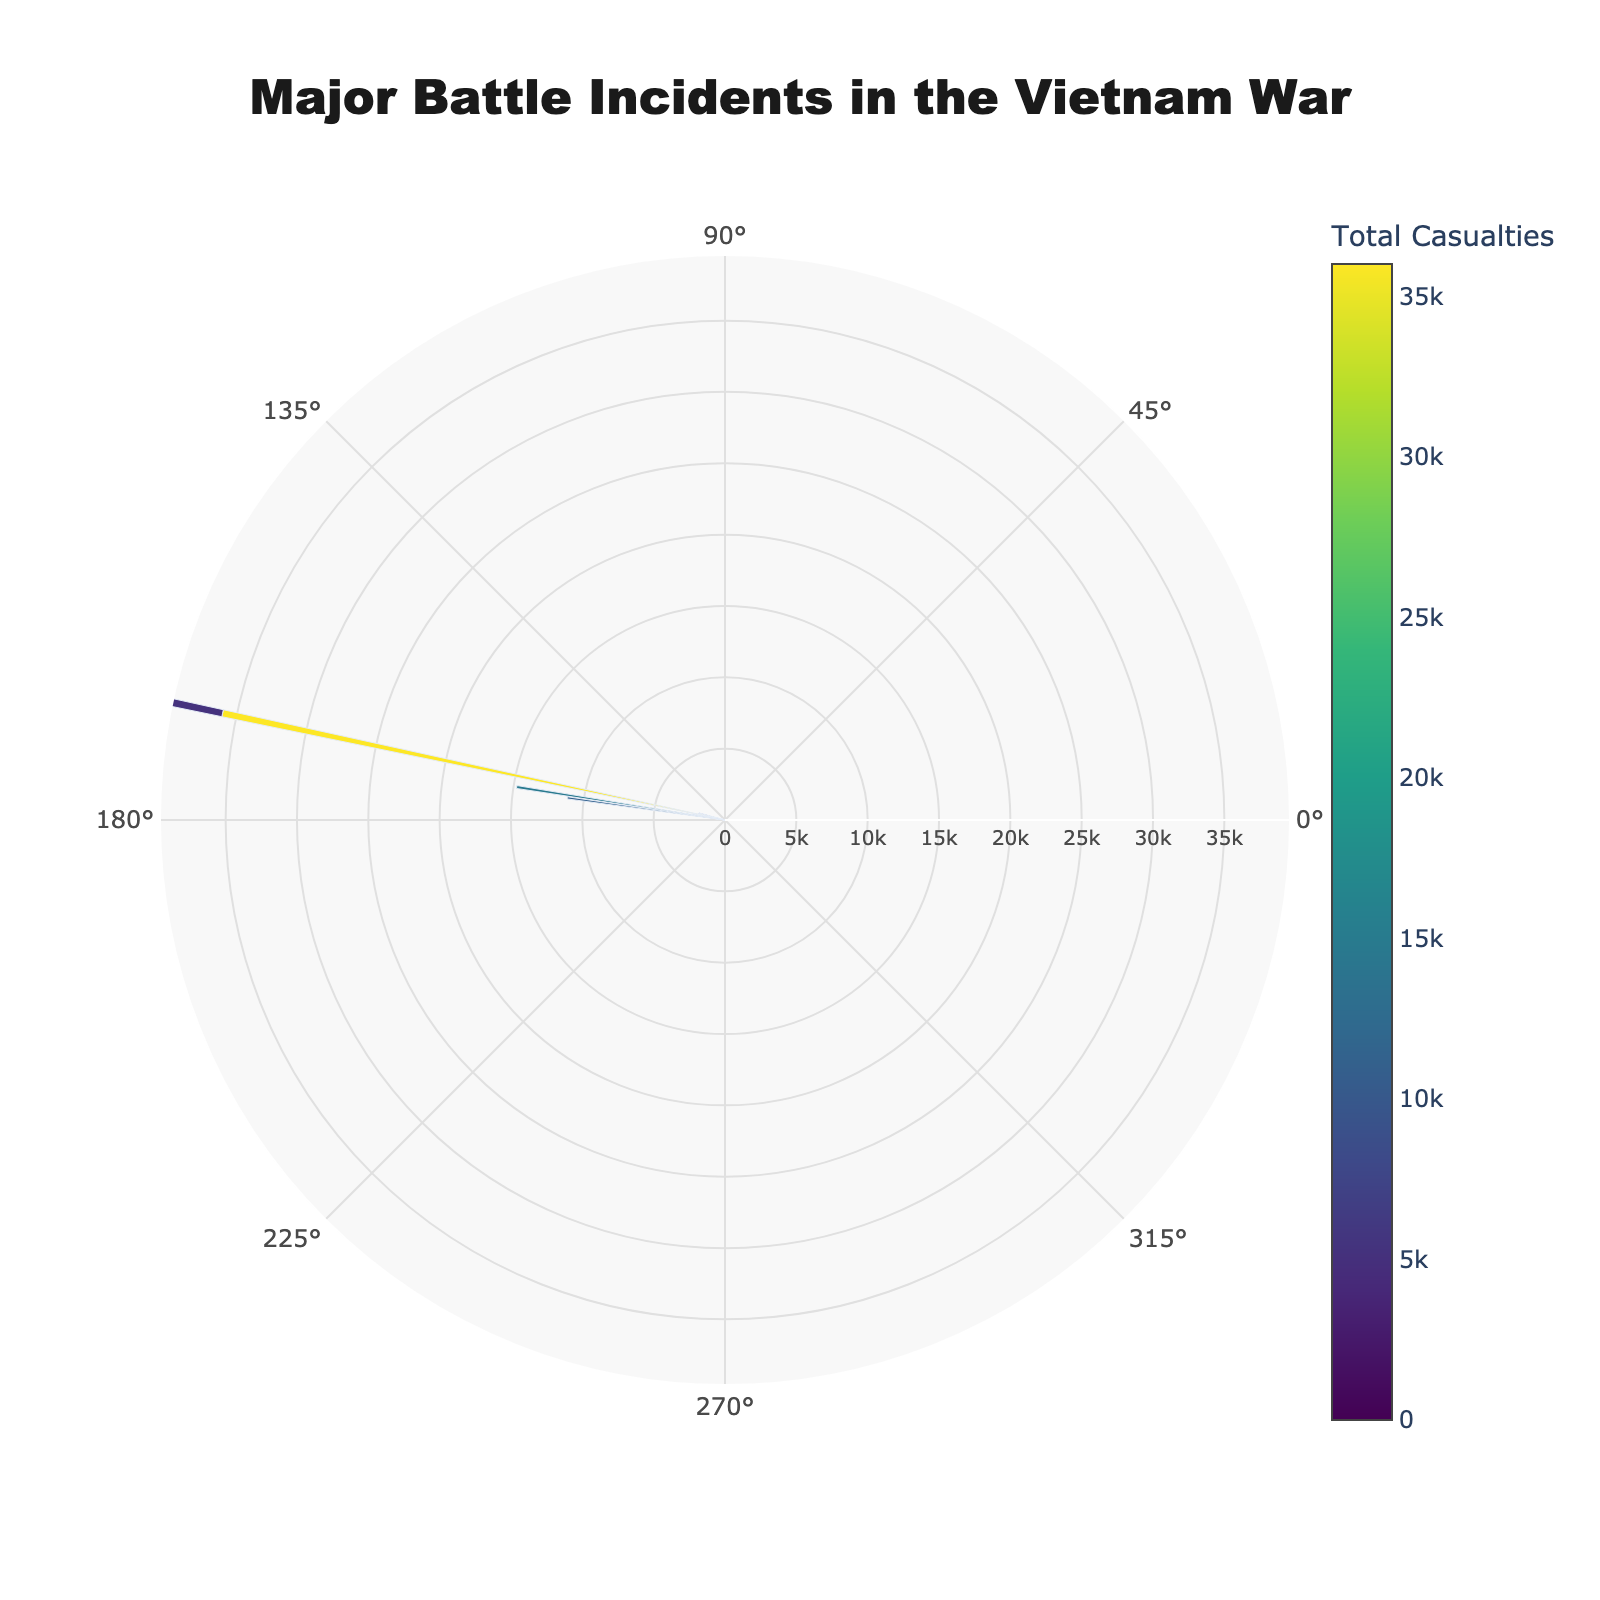What is the total number of casualties during the Tet Offensive? The rose chart displays casualties in hover text. For the Tet Offensive, hover text shows 'US: 4000' and 'Viet Cong: 32000'. Adding these gives 4000 + 32000 = 36000.
Answer: 36000 Which year saw the highest number of total casualties in a single incident? Observing the radial lengths, 1971 has the highest value. The hover text confirms it’s Operation Lam Son 719 with total casualties of 14782.
Answer: 1971 How many incidents recorded more Viet Cong casualties than US casualties? By reviewing the hover text for each incident, we tally how often Viet Cong casualties exceed US casualties. All twelve incidents have higher Viet Cong casualties.
Answer: 12 What is the average number of US casualties across all incidents? Sum all US casualties from hover text: 5+96+14+34+72+155+4000+216+72+338+1082+1500 = 7584. Divide by 12 incidents: 7584/12 = 632.
Answer: 632 Which incident in 1968 recorded more casualties, Tet Offensive or Battle of Hue? Hover text shows Tet Offensive with 36000 total casualties and Battle of Hue with 5216 total casualties. Tet Offensive is higher.
Answer: Tet Offensive What geographical location recorded the highest total number of incidents? Cross-reference incidents to locations and count: South Vietnam has Battle of Bien Hoa, Tet Offensive, and Easter Offensive, which is more than other locations.
Answer: South Vietnam Which incident has the lowest total casualties? Hover text shows Battle of Bien Hoa in 1964 with 35 total casualties (5 US + 30 Viet Cong).
Answer: Battle of Bien Hoa How do the total casualties compare between Operation Cedar Falls and Hamburger Hill? Hover text indicates Operation Cedar Falls with 792 casualties and Hamburger Hill with 702 casualties. Operation Cedar Falls has more.
Answer: Operation Cedar Falls How did the total casualties in 1970 compare to those in 1971? 1970’s Cambodian Incursion had 2378 casualties, and 1971’s Operation Lam Son 719 had 14782. Thus, 1970 had fewer casualties.
Answer: 1970 had fewer What was the total number of casualties in incidents occurring in the Central Highlands compared to Quang Ngai Province? Hover text shows Battle of Ia Drang in Central Highlands with 1896 casualties and Operation Double Eagle in Quang Ngai with 190. Central Highlands had more casualties (1896 vs. 190).
Answer: Central Highlands 